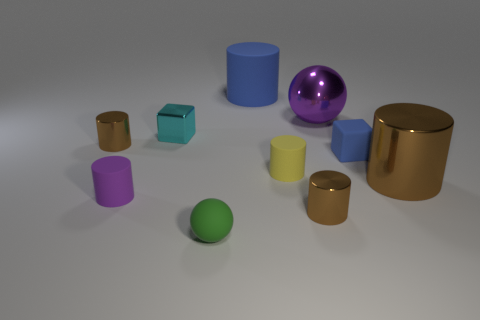What number of things are both to the right of the yellow object and in front of the purple matte thing?
Keep it short and to the point. 1. What color is the matte thing that is behind the small brown metallic cylinder left of the small green rubber ball?
Provide a succinct answer. Blue. What number of tiny objects have the same color as the large matte cylinder?
Your answer should be compact. 1. Do the large metal ball and the rubber cylinder to the left of the small shiny block have the same color?
Make the answer very short. Yes. Are there fewer blue matte objects than big metallic cylinders?
Provide a succinct answer. No. Is the number of tiny metallic things that are behind the rubber sphere greater than the number of large brown shiny things on the left side of the tiny cyan metallic cube?
Keep it short and to the point. Yes. Is the big purple sphere made of the same material as the cyan block?
Provide a short and direct response. Yes. How many metallic cubes are on the right side of the tiny brown thing to the right of the small sphere?
Ensure brevity in your answer.  0. Is the color of the tiny cylinder that is in front of the tiny purple matte cylinder the same as the large shiny cylinder?
Your answer should be very brief. Yes. What number of objects are either tiny red cubes or blue rubber objects that are on the left side of the matte cube?
Your response must be concise. 1. 